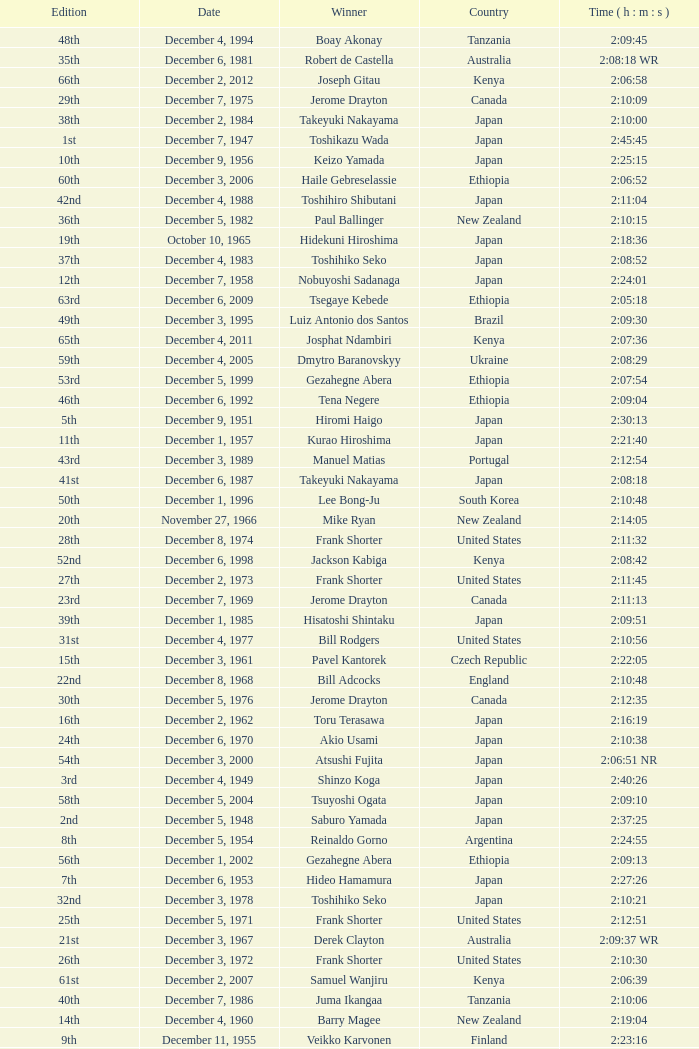On what date did Lee Bong-Ju win in 2:10:48? December 1, 1996. 